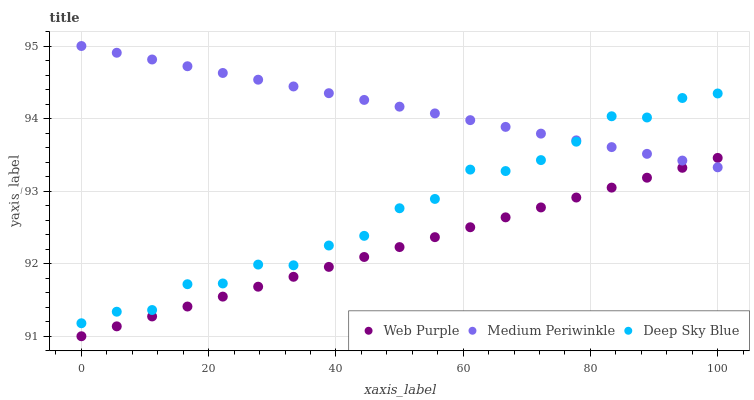Does Web Purple have the minimum area under the curve?
Answer yes or no. Yes. Does Medium Periwinkle have the maximum area under the curve?
Answer yes or no. Yes. Does Deep Sky Blue have the minimum area under the curve?
Answer yes or no. No. Does Deep Sky Blue have the maximum area under the curve?
Answer yes or no. No. Is Medium Periwinkle the smoothest?
Answer yes or no. Yes. Is Deep Sky Blue the roughest?
Answer yes or no. Yes. Is Deep Sky Blue the smoothest?
Answer yes or no. No. Is Medium Periwinkle the roughest?
Answer yes or no. No. Does Web Purple have the lowest value?
Answer yes or no. Yes. Does Deep Sky Blue have the lowest value?
Answer yes or no. No. Does Medium Periwinkle have the highest value?
Answer yes or no. Yes. Does Deep Sky Blue have the highest value?
Answer yes or no. No. Is Web Purple less than Deep Sky Blue?
Answer yes or no. Yes. Is Deep Sky Blue greater than Web Purple?
Answer yes or no. Yes. Does Medium Periwinkle intersect Web Purple?
Answer yes or no. Yes. Is Medium Periwinkle less than Web Purple?
Answer yes or no. No. Is Medium Periwinkle greater than Web Purple?
Answer yes or no. No. Does Web Purple intersect Deep Sky Blue?
Answer yes or no. No. 